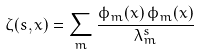Convert formula to latex. <formula><loc_0><loc_0><loc_500><loc_500>\zeta ( s , x ) = \sum _ { m } \frac { \phi _ { m } ( x ) \, \phi _ { m } ( x ) } { \lambda _ { m } ^ { s } }</formula> 